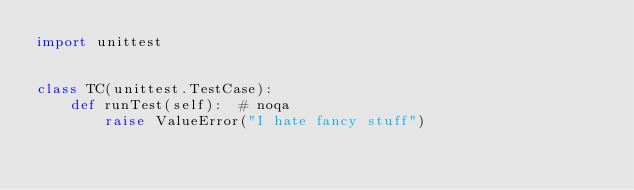<code> <loc_0><loc_0><loc_500><loc_500><_Python_>import unittest


class TC(unittest.TestCase):
    def runTest(self):  # noqa
        raise ValueError("I hate fancy stuff")
</code> 